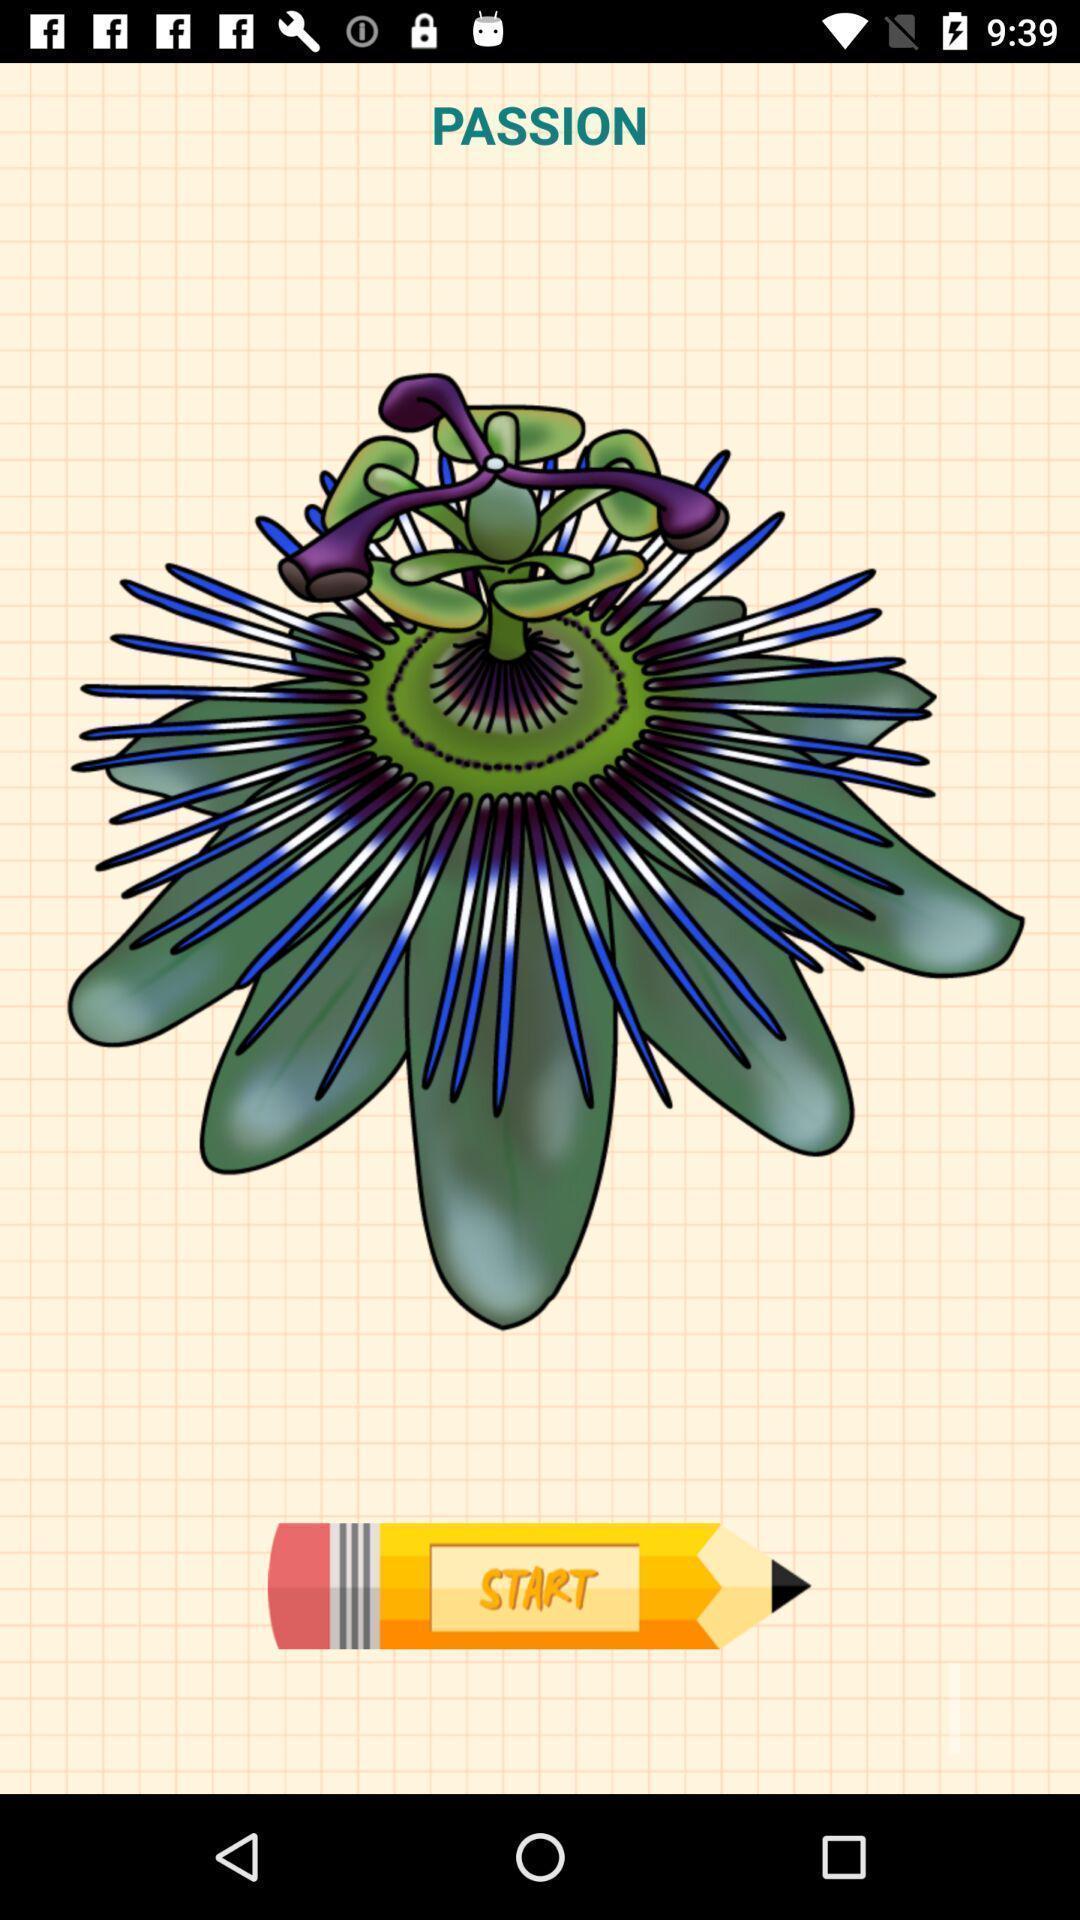Describe this image in words. Welcome page displaying an image. 